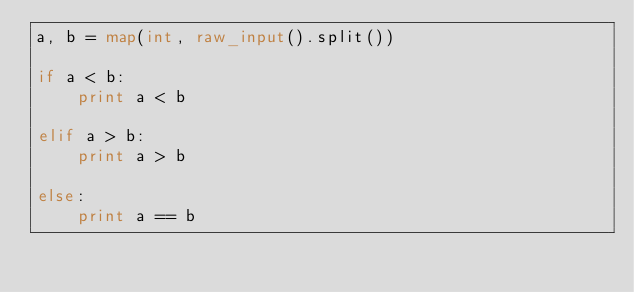Convert code to text. <code><loc_0><loc_0><loc_500><loc_500><_Python_>a, b = map(int, raw_input().split())

if a < b:
    print a < b

elif a > b:
    print a > b

else:
    print a == b</code> 